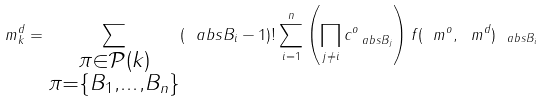<formula> <loc_0><loc_0><loc_500><loc_500>m _ { k } ^ { d } = \sum _ { \substack { \pi \in \mathcal { P } ( k ) \\ \pi = \{ B _ { 1 } , \dots , B _ { n } \} } } ( \ a b s { B _ { i } } - 1 ) ! \sum _ { i = 1 } ^ { n } \left ( \prod _ { j \neq i } c _ { \ a b s { B _ { j } } } ^ { o } \right ) f ( \ m ^ { o } , \ m ^ { d } ) _ { \ a b s { B _ { i } } }</formula> 